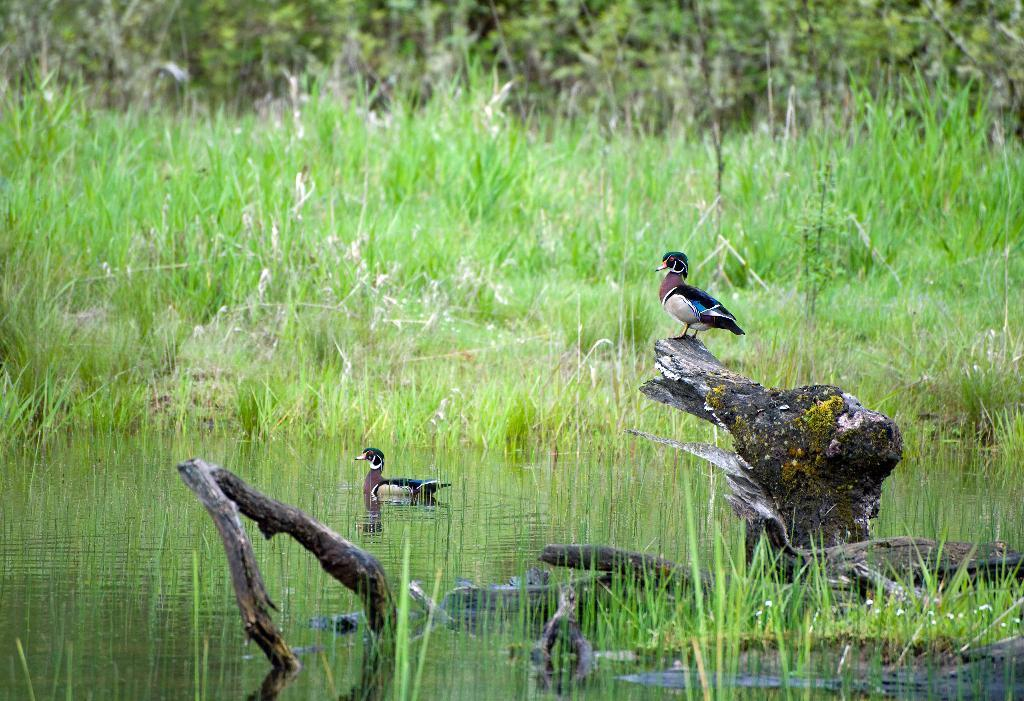What animals can be seen in the water in the foreground? There are two birds in the water in the foreground. What is the position of one of the birds in the image? One bird is sitting on a tree trunk. What type of vegetation is visible in the background? There is grass and trees visible in the background. Can you determine the time of day the image was taken? The image might have been taken during the day, as there is sufficient light to see the details. What type of knee injury can be seen on the bird sitting on the tree trunk? There is no indication of a knee injury on the bird sitting on the tree trunk, as the image only shows the birds and their surroundings. 